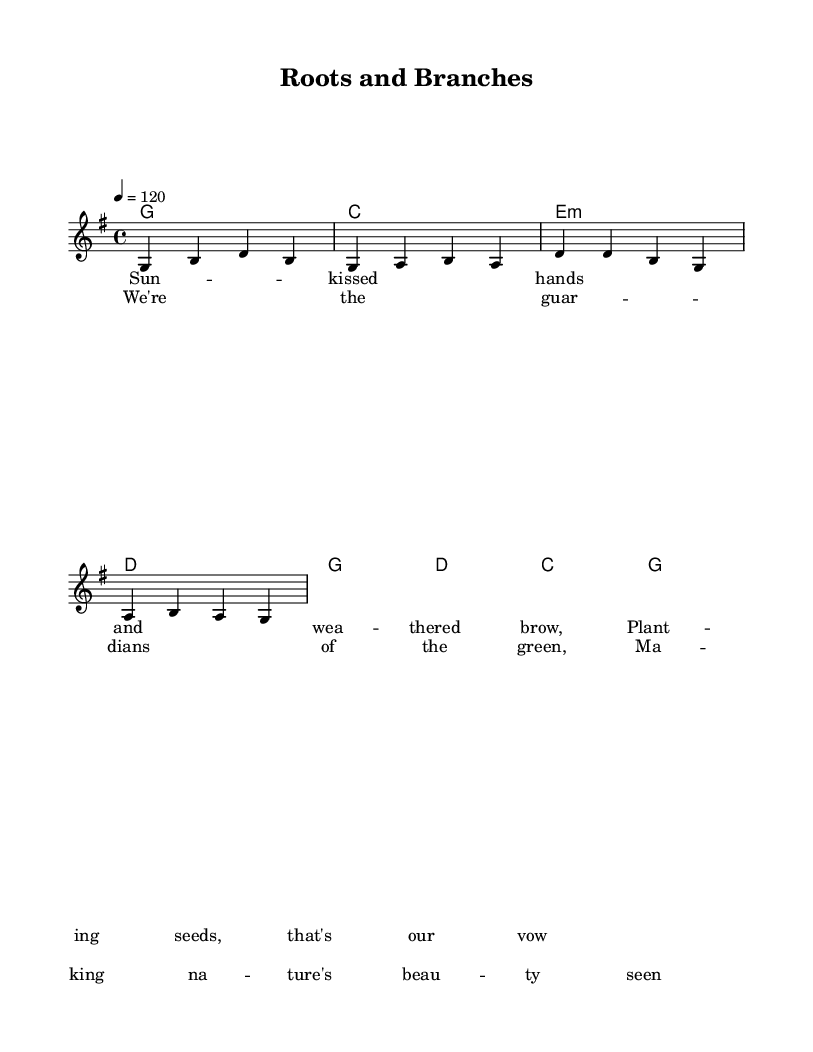What is the key signature of this music? The key signature is G major, which contains one sharp. This can be identified from the key signature indication at the beginning of the staff.
Answer: G major What is the time signature of this music? The time signature is 4/4, which is indicated at the beginning of the score. This means there are four beats in each measure.
Answer: 4/4 What is the tempo marking in beats per minute? The tempo marking indicates a speed of 120 beats per minute, written as "4 = 120" in the score.
Answer: 120 How many measures are in the verse section? The verse section contains four measures; this can be determined by counting the measures in the melody part designated as the verse.
Answer: 4 Which chord is played on the first beat of the chorus? The first beat of the chorus features the D major chord, identified from the chord symbols indicated in the score.
Answer: D What is the lyrical theme of the song? The lyrics celebrate outdoor laborers who are dedicated to planting and nurturing nature, as shown in the words presented in the score.
Answer: Guardians of the green Is there a repetition of melody between the verse and chorus? Yes, the melody structure is similar in both the verse and chorus, indicating a common practice in Country Rock for cohesion.
Answer: Yes 